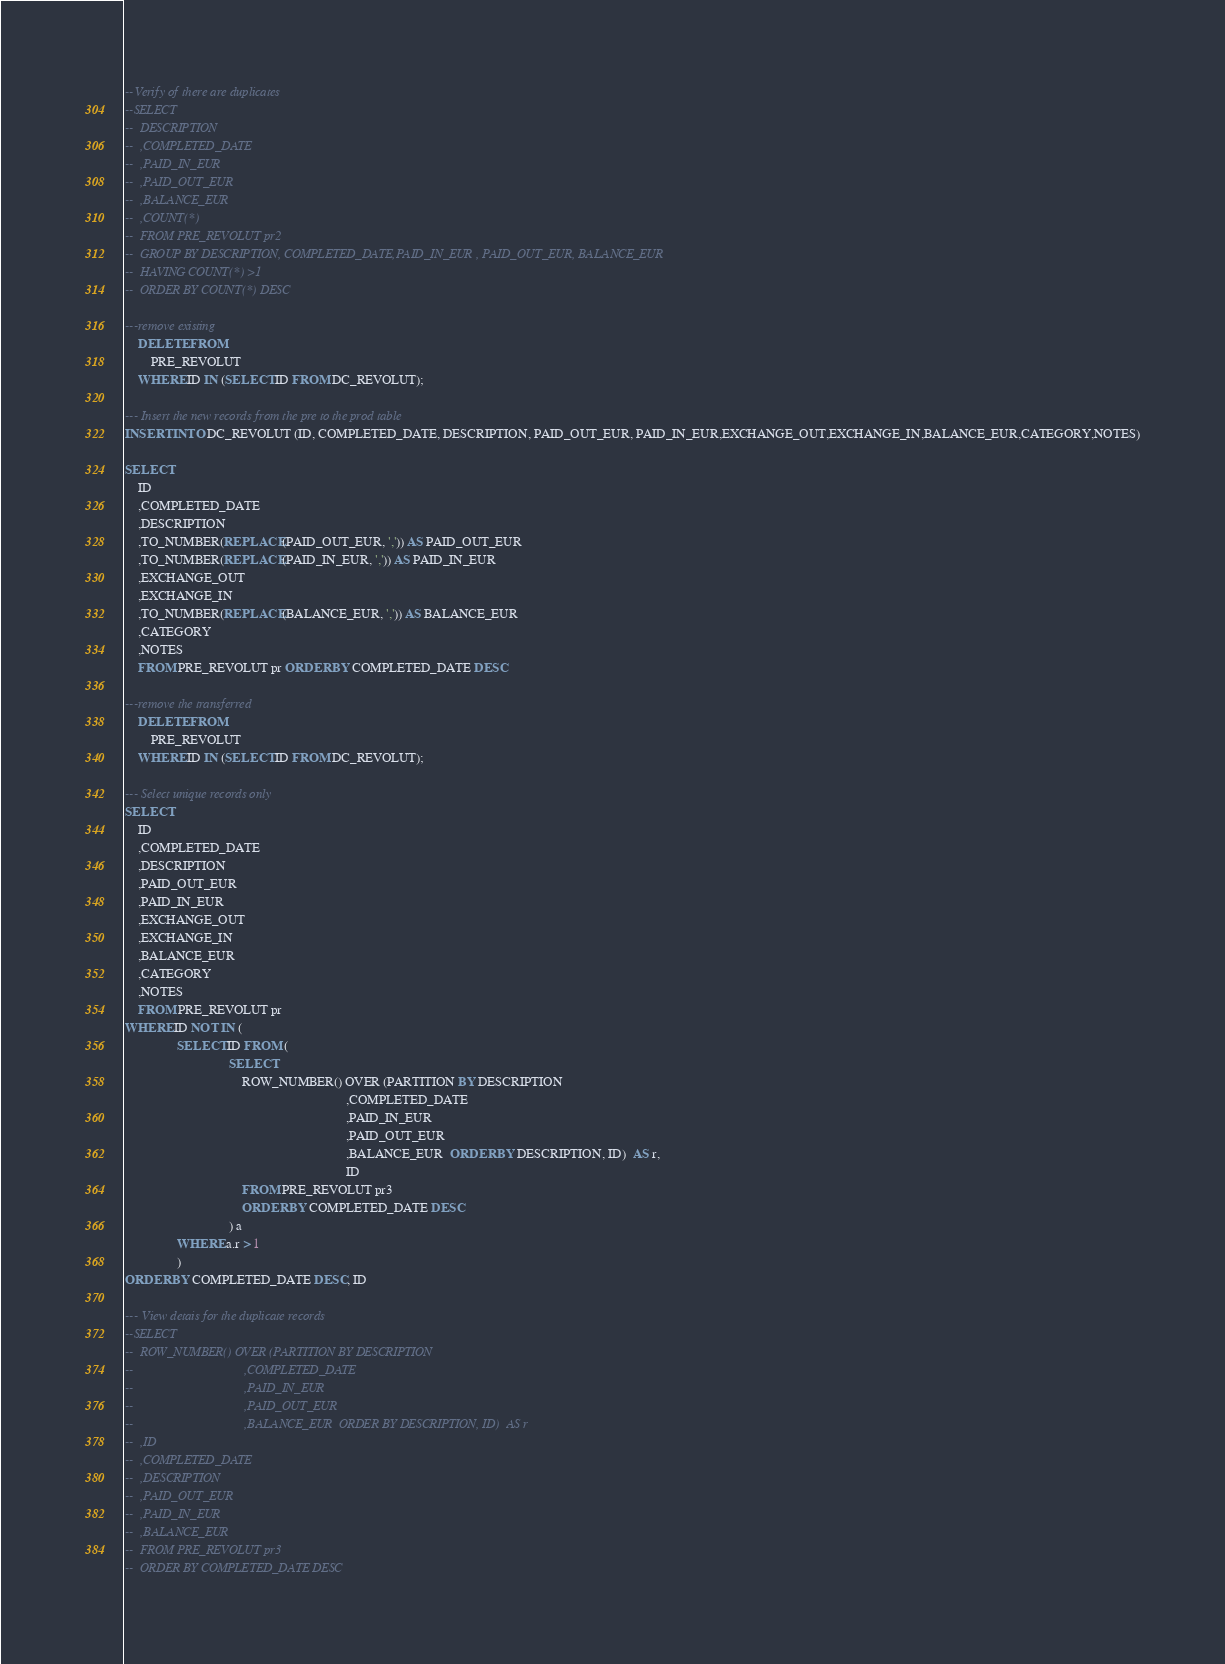Convert code to text. <code><loc_0><loc_0><loc_500><loc_500><_SQL_>--Verify of there are duplicates
--SELECT
--	DESCRIPTION
--	,COMPLETED_DATE
--	,PAID_IN_EUR
--	,PAID_OUT_EUR
--	,BALANCE_EUR 
--	,COUNT(*) 
--	FROM PRE_REVOLUT pr2 
--	GROUP BY DESCRIPTION, COMPLETED_DATE,PAID_IN_EUR , PAID_OUT_EUR, BALANCE_EUR
--	HAVING COUNT(*) >1 
--	ORDER BY COUNT(*) DESC

---remove existing
    DELETE FROM 
        PRE_REVOLUT
    WHERE ID IN (SELECT ID FROM DC_REVOLUT);

--- Insert the new records from the pre to the prod table
INSERT INTO DC_REVOLUT (ID, COMPLETED_DATE, DESCRIPTION, PAID_OUT_EUR, PAID_IN_EUR,EXCHANGE_OUT,EXCHANGE_IN,BALANCE_EUR,CATEGORY,NOTES)

SELECT
	ID
	,COMPLETED_DATE
	,DESCRIPTION 
	,TO_NUMBER(REPLACE(PAID_OUT_EUR, ',')) AS PAID_OUT_EUR
	,TO_NUMBER(REPLACE(PAID_IN_EUR, ',')) AS PAID_IN_EUR 
	,EXCHANGE_OUT 
	,EXCHANGE_IN 
	,TO_NUMBER(REPLACE(BALANCE_EUR, ',')) AS BALANCE_EUR 
	,CATEGORY 
	,NOTES 
	FROM PRE_REVOLUT pr ORDER BY COMPLETED_DATE DESC

---remove the transferred
    DELETE FROM 
        PRE_REVOLUT
    WHERE ID IN (SELECT ID FROM DC_REVOLUT);

--- Select unique records only
SELECT
	ID
	,COMPLETED_DATE
	,DESCRIPTION 
	,PAID_OUT_EUR 
	,PAID_IN_EUR 
	,EXCHANGE_OUT 
	,EXCHANGE_IN 
	,BALANCE_EUR 
	,CATEGORY 
	,NOTES 
	FROM PRE_REVOLUT pr 
WHERE ID NOT IN (
				SELECT ID FROM (
								SELECT 
									ROW_NUMBER() OVER (PARTITION BY DESCRIPTION
																	,COMPLETED_DATE
																	,PAID_IN_EUR
																	,PAID_OUT_EUR
																	,BALANCE_EUR  ORDER BY DESCRIPTION, ID)  AS r,
																	ID
									FROM PRE_REVOLUT pr3
									ORDER BY COMPLETED_DATE DESC
								) a
				WHERE a.r > 1
				)
ORDER BY COMPLETED_DATE DESC, ID

--- View detais for the duplicate records
--SELECT 
--	ROW_NUMBER() OVER (PARTITION BY DESCRIPTION
--									,COMPLETED_DATE
--									,PAID_IN_EUR
--									,PAID_OUT_EUR
--									,BALANCE_EUR  ORDER BY DESCRIPTION, ID)  AS r
--	,ID
--	,COMPLETED_DATE
--	,DESCRIPTION
--	,PAID_OUT_EUR 
--	,PAID_IN_EUR
--	,BALANCE_EUR
--	FROM PRE_REVOLUT pr3
--	ORDER BY COMPLETED_DATE DESC
</code> 